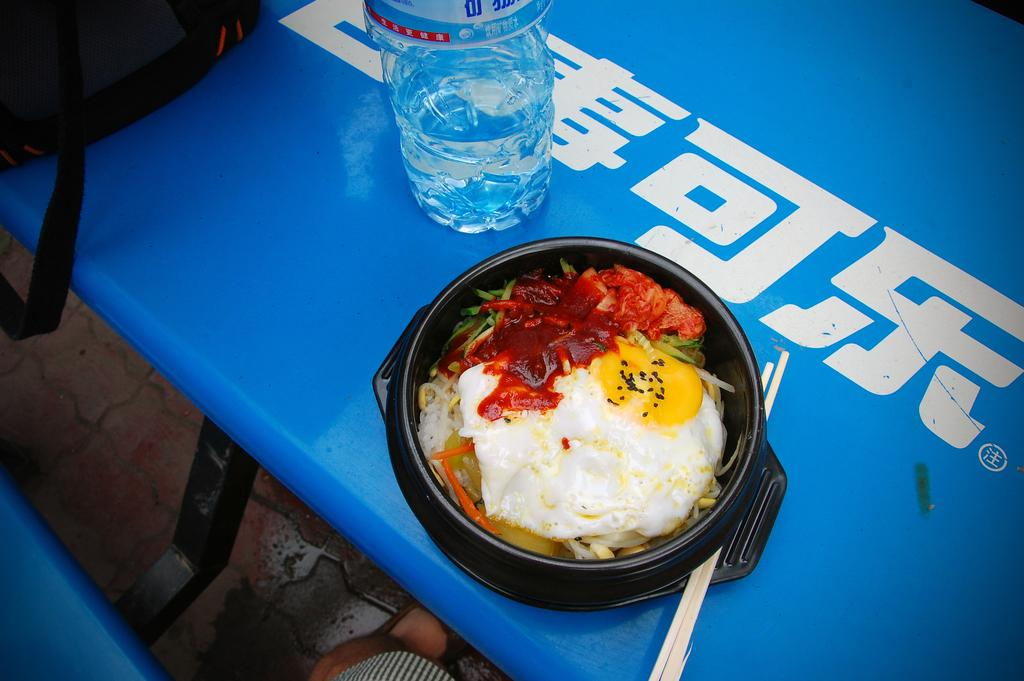What is in the image that can be used for holding or pouring liquids? There is a bottle in the image. What is in the image that can be used for eating food? There is a bowl full of food in the image, and chopsticks are visible in the image. What is on the table in the image that might be used for carrying items? There is a bag on the table in the image. What list can be seen on the table in the image? There is no list present on the table in the image. What emotion is expressed by the objects in the image? The objects in the image do not express emotions; they are inanimate. 